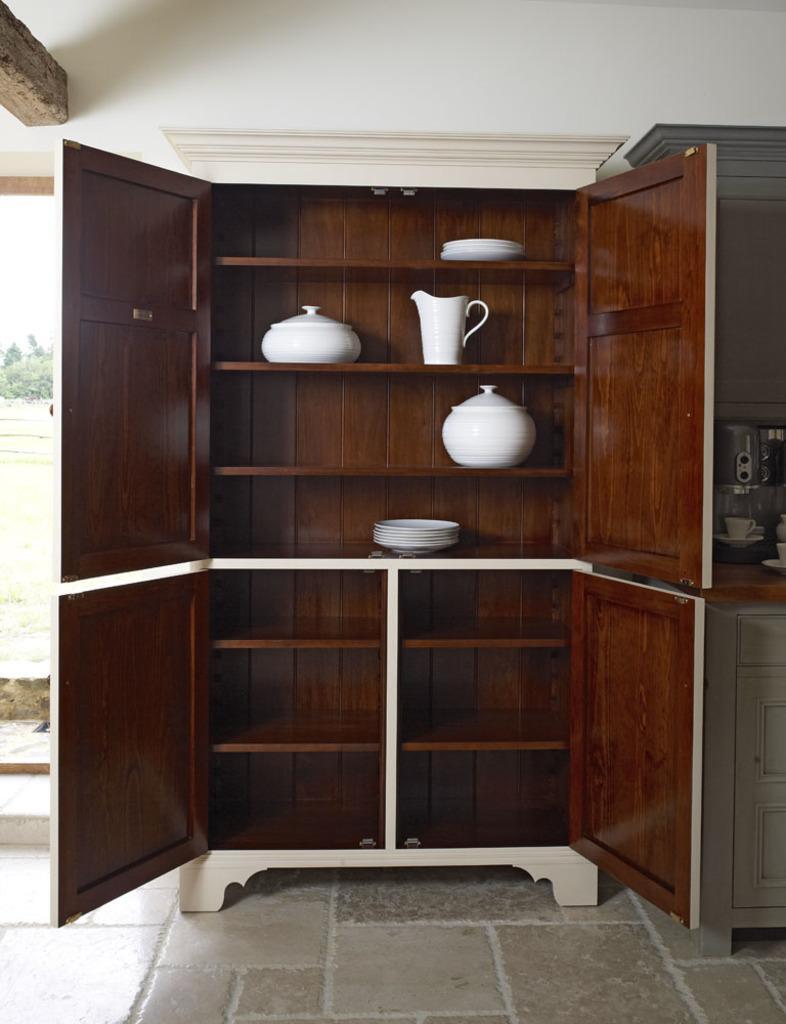Describe this image in one or two sentences. In this image I can see few plates and few objects inside the cupboard. I can see few objects on the table. Back I can see the white color wall. 